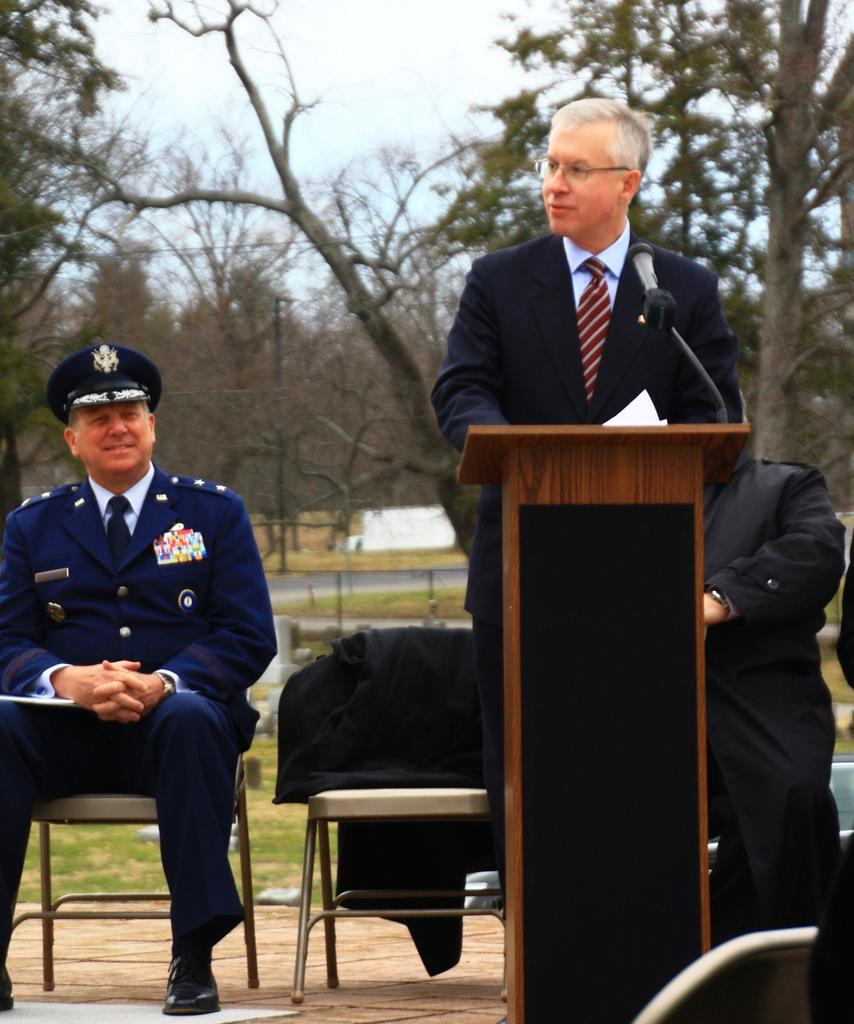Who is the main subject in the image? There is a man in the image. What is the man doing in the image? The man is standing in the image. What object is in front of the man? There is a podium in front of the man. What are the people in the image doing? People are sitting at the back of the man. What type of jam is the man holding in the image? There is no jam present in the image; the man is not holding anything. 